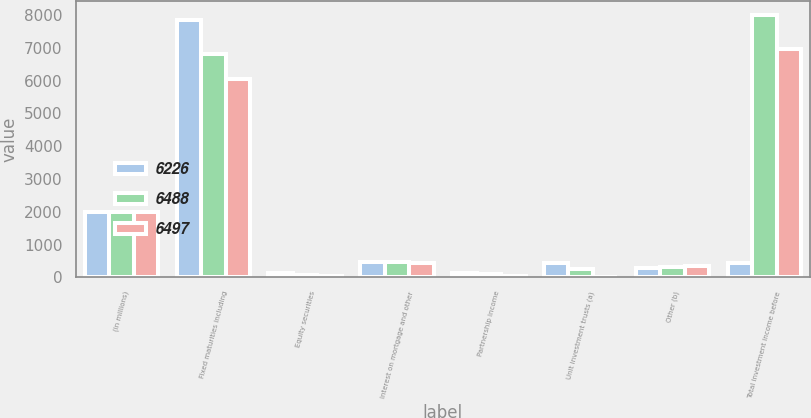Convert chart. <chart><loc_0><loc_0><loc_500><loc_500><stacked_bar_chart><ecel><fcel>(in millions)<fcel>Fixed maturities including<fcel>Equity securities<fcel>Interest on mortgage and other<fcel>Partnership income<fcel>Unit investment trusts (a)<fcel>Other (b)<fcel>Total investment income before<nl><fcel>6226<fcel>2007<fcel>7846<fcel>135<fcel>466<fcel>128<fcel>439<fcel>275<fcel>439<nl><fcel>6488<fcel>2006<fcel>6820<fcel>80<fcel>454<fcel>94<fcel>259<fcel>301<fcel>8008<nl><fcel>6497<fcel>2005<fcel>6059<fcel>51<fcel>447<fcel>57<fcel>4<fcel>357<fcel>6975<nl></chart> 